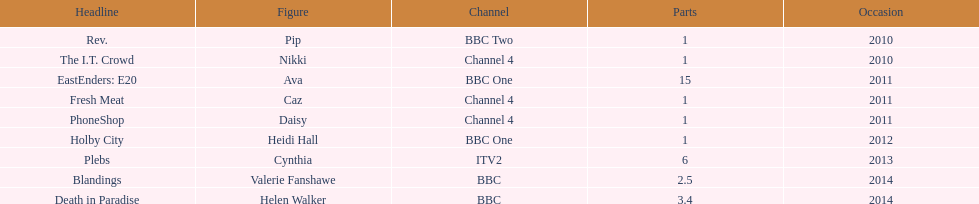How many television credits does this actress have? 9. 